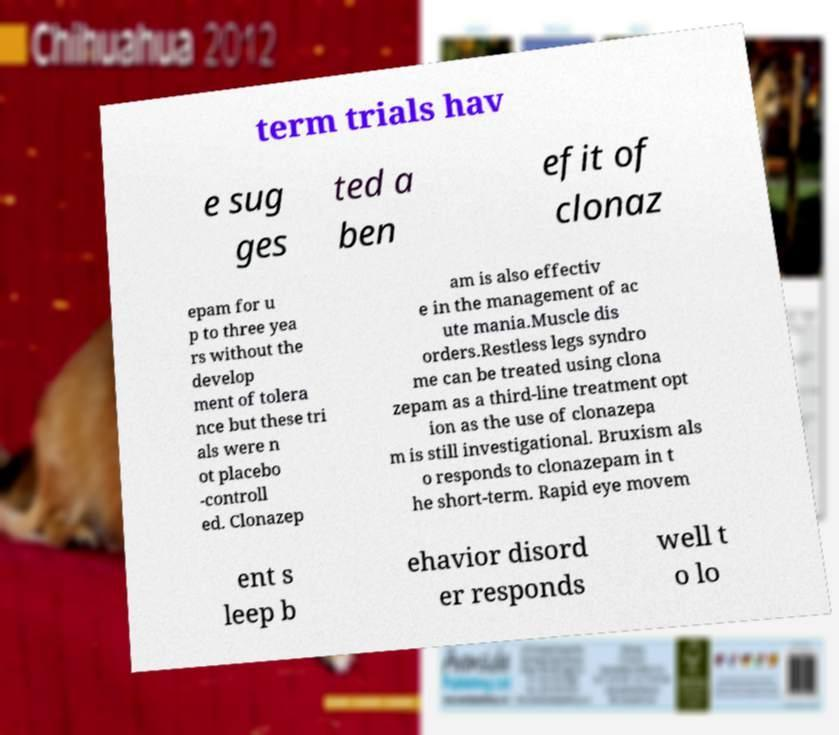For documentation purposes, I need the text within this image transcribed. Could you provide that? term trials hav e sug ges ted a ben efit of clonaz epam for u p to three yea rs without the develop ment of tolera nce but these tri als were n ot placebo -controll ed. Clonazep am is also effectiv e in the management of ac ute mania.Muscle dis orders.Restless legs syndro me can be treated using clona zepam as a third-line treatment opt ion as the use of clonazepa m is still investigational. Bruxism als o responds to clonazepam in t he short-term. Rapid eye movem ent s leep b ehavior disord er responds well t o lo 